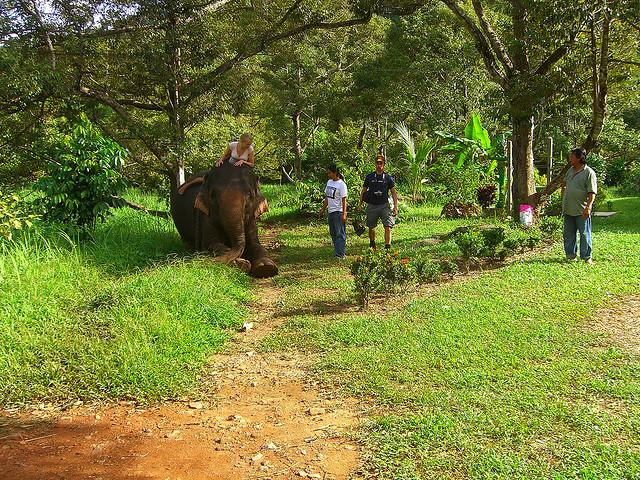Why is the elephant laying down on the left with the tourist on top?

Choices:
A) tired
B) sleepy
C) sick
D) afraid tired 